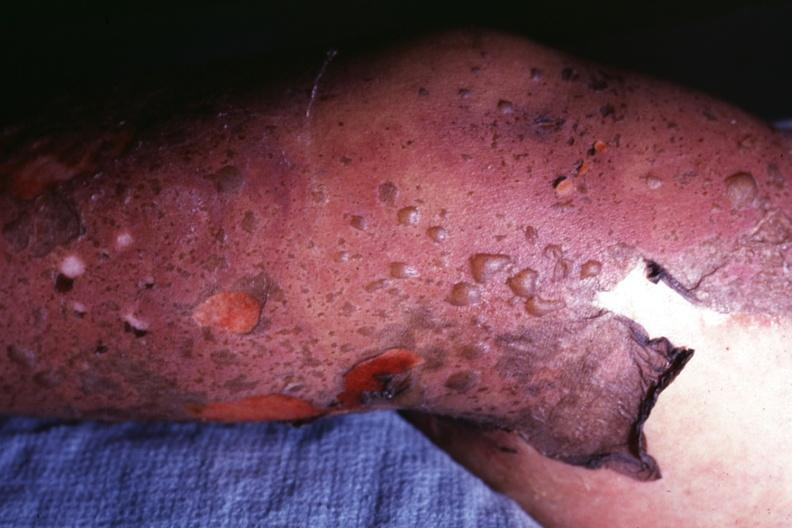what is correct diagnosis as i do not have protocol?
Answer the question using a single word or phrase. This 